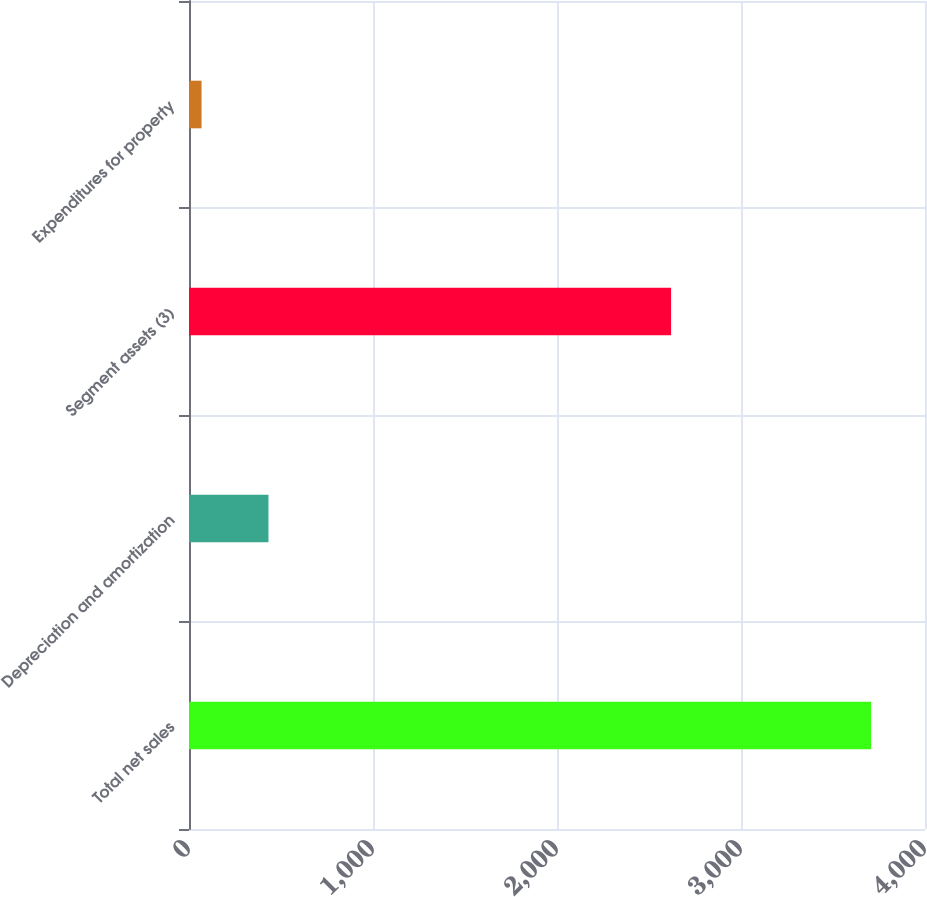<chart> <loc_0><loc_0><loc_500><loc_500><bar_chart><fcel>Total net sales<fcel>Depreciation and amortization<fcel>Segment assets (3)<fcel>Expenditures for property<nl><fcel>3707<fcel>431.9<fcel>2620<fcel>68<nl></chart> 